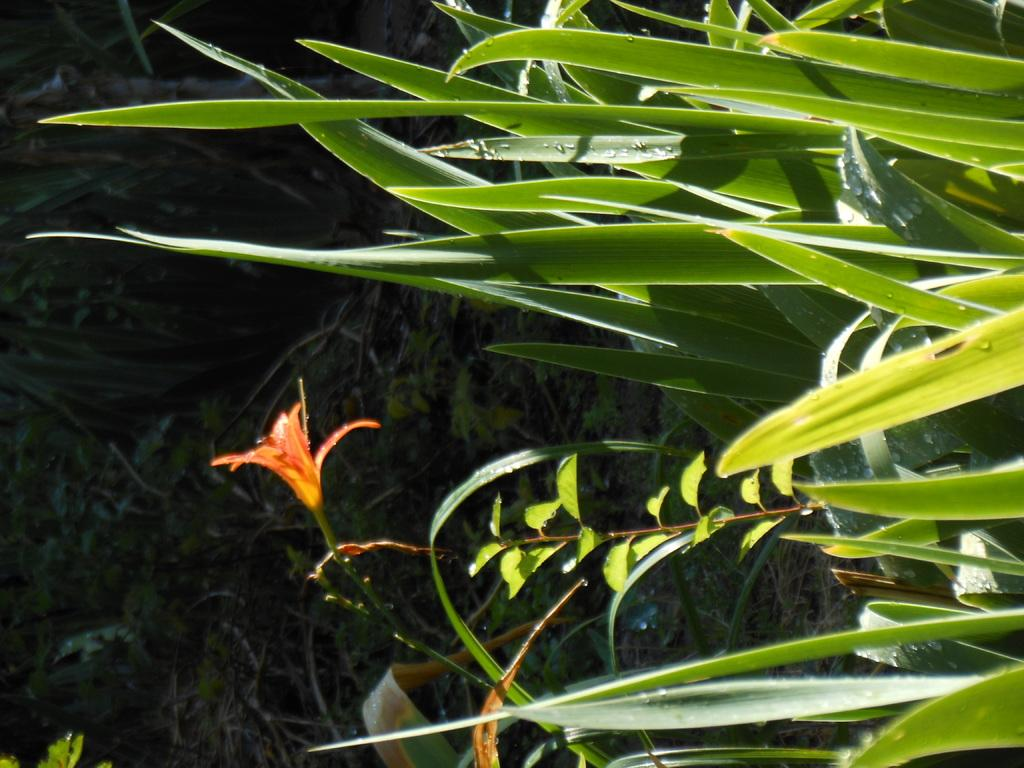What is the person in the image doing? The person is sitting on a bench in a park. What can be seen in the background of the image? The background of the image is not specified, but it is likely to be park scenery. Is there any activity or object related to the person in the image? The person's activity is not specified, but they are sitting on a bench, which suggests they might be resting or enjoying the park. What type of balloon is the person holding in the image? There is no balloon present in the image; the person is sitting on a bench in a park. What ingredients are used to make the stew that the person is eating in the image? There is no stew present in the image; the person is sitting on a bench in a park. 